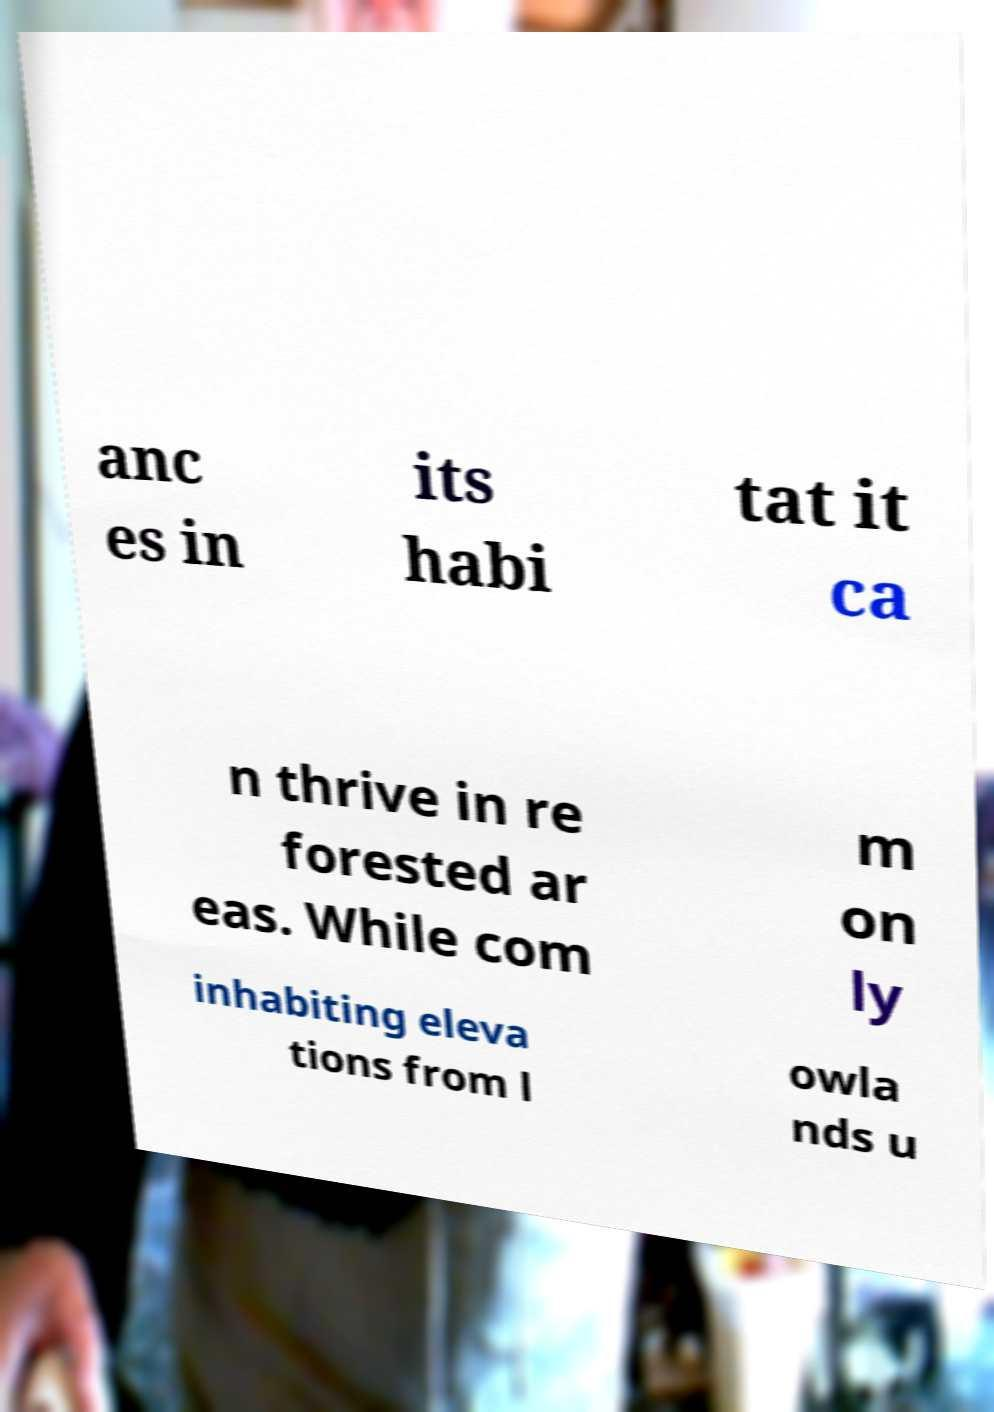For documentation purposes, I need the text within this image transcribed. Could you provide that? anc es in its habi tat it ca n thrive in re forested ar eas. While com m on ly inhabiting eleva tions from l owla nds u 